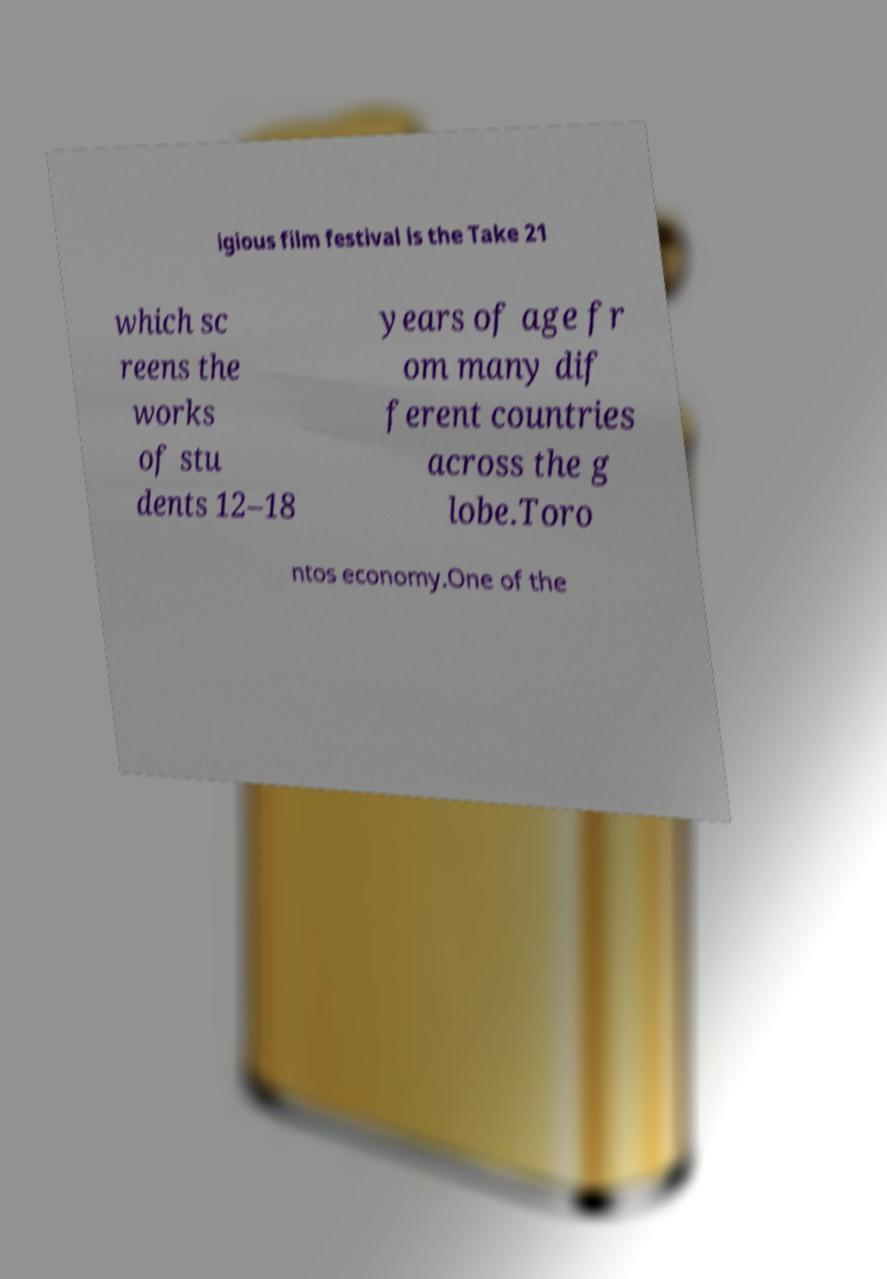Please read and relay the text visible in this image. What does it say? igious film festival is the Take 21 which sc reens the works of stu dents 12–18 years of age fr om many dif ferent countries across the g lobe.Toro ntos economy.One of the 